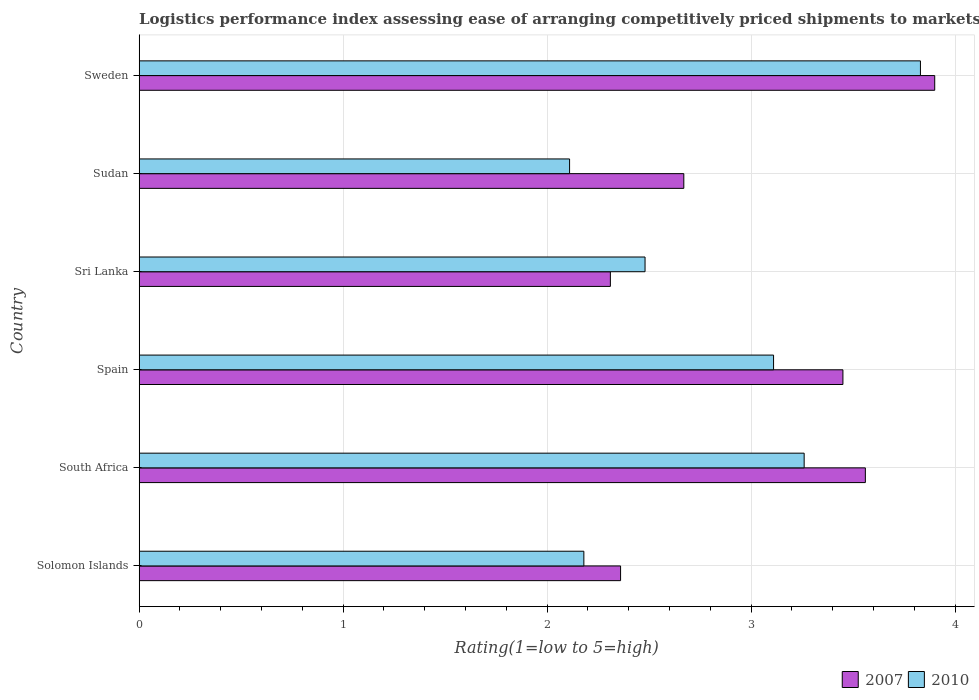Are the number of bars per tick equal to the number of legend labels?
Offer a terse response. Yes. Are the number of bars on each tick of the Y-axis equal?
Give a very brief answer. Yes. How many bars are there on the 5th tick from the top?
Give a very brief answer. 2. How many bars are there on the 2nd tick from the bottom?
Make the answer very short. 2. What is the label of the 5th group of bars from the top?
Ensure brevity in your answer.  South Africa. What is the Logistic performance index in 2007 in Sweden?
Your answer should be compact. 3.9. Across all countries, what is the minimum Logistic performance index in 2007?
Ensure brevity in your answer.  2.31. In which country was the Logistic performance index in 2007 maximum?
Your response must be concise. Sweden. In which country was the Logistic performance index in 2010 minimum?
Give a very brief answer. Sudan. What is the total Logistic performance index in 2007 in the graph?
Your response must be concise. 18.25. What is the difference between the Logistic performance index in 2010 in Solomon Islands and that in Spain?
Your answer should be compact. -0.93. What is the difference between the Logistic performance index in 2010 in Spain and the Logistic performance index in 2007 in Sudan?
Keep it short and to the point. 0.44. What is the average Logistic performance index in 2007 per country?
Offer a terse response. 3.04. What is the difference between the Logistic performance index in 2010 and Logistic performance index in 2007 in Solomon Islands?
Your answer should be very brief. -0.18. What is the ratio of the Logistic performance index in 2007 in Solomon Islands to that in Spain?
Your answer should be compact. 0.68. Is the Logistic performance index in 2007 in Solomon Islands less than that in Sudan?
Keep it short and to the point. Yes. Is the difference between the Logistic performance index in 2010 in South Africa and Sweden greater than the difference between the Logistic performance index in 2007 in South Africa and Sweden?
Your answer should be very brief. No. What is the difference between the highest and the second highest Logistic performance index in 2007?
Provide a succinct answer. 0.34. What is the difference between the highest and the lowest Logistic performance index in 2010?
Your answer should be very brief. 1.72. How many bars are there?
Your answer should be compact. 12. Are all the bars in the graph horizontal?
Give a very brief answer. Yes. How many countries are there in the graph?
Your answer should be compact. 6. Does the graph contain any zero values?
Ensure brevity in your answer.  No. How many legend labels are there?
Your answer should be compact. 2. What is the title of the graph?
Keep it short and to the point. Logistics performance index assessing ease of arranging competitively priced shipments to markets. What is the label or title of the X-axis?
Your response must be concise. Rating(1=low to 5=high). What is the Rating(1=low to 5=high) of 2007 in Solomon Islands?
Provide a short and direct response. 2.36. What is the Rating(1=low to 5=high) in 2010 in Solomon Islands?
Give a very brief answer. 2.18. What is the Rating(1=low to 5=high) of 2007 in South Africa?
Ensure brevity in your answer.  3.56. What is the Rating(1=low to 5=high) in 2010 in South Africa?
Your response must be concise. 3.26. What is the Rating(1=low to 5=high) in 2007 in Spain?
Ensure brevity in your answer.  3.45. What is the Rating(1=low to 5=high) in 2010 in Spain?
Make the answer very short. 3.11. What is the Rating(1=low to 5=high) in 2007 in Sri Lanka?
Offer a terse response. 2.31. What is the Rating(1=low to 5=high) of 2010 in Sri Lanka?
Offer a very short reply. 2.48. What is the Rating(1=low to 5=high) of 2007 in Sudan?
Your answer should be compact. 2.67. What is the Rating(1=low to 5=high) in 2010 in Sudan?
Make the answer very short. 2.11. What is the Rating(1=low to 5=high) in 2007 in Sweden?
Your response must be concise. 3.9. What is the Rating(1=low to 5=high) of 2010 in Sweden?
Make the answer very short. 3.83. Across all countries, what is the maximum Rating(1=low to 5=high) in 2010?
Provide a short and direct response. 3.83. Across all countries, what is the minimum Rating(1=low to 5=high) in 2007?
Provide a short and direct response. 2.31. Across all countries, what is the minimum Rating(1=low to 5=high) in 2010?
Ensure brevity in your answer.  2.11. What is the total Rating(1=low to 5=high) of 2007 in the graph?
Keep it short and to the point. 18.25. What is the total Rating(1=low to 5=high) in 2010 in the graph?
Provide a short and direct response. 16.97. What is the difference between the Rating(1=low to 5=high) of 2010 in Solomon Islands and that in South Africa?
Your answer should be very brief. -1.08. What is the difference between the Rating(1=low to 5=high) in 2007 in Solomon Islands and that in Spain?
Your answer should be very brief. -1.09. What is the difference between the Rating(1=low to 5=high) of 2010 in Solomon Islands and that in Spain?
Keep it short and to the point. -0.93. What is the difference between the Rating(1=low to 5=high) of 2007 in Solomon Islands and that in Sudan?
Provide a short and direct response. -0.31. What is the difference between the Rating(1=low to 5=high) in 2010 in Solomon Islands and that in Sudan?
Provide a succinct answer. 0.07. What is the difference between the Rating(1=low to 5=high) in 2007 in Solomon Islands and that in Sweden?
Offer a terse response. -1.54. What is the difference between the Rating(1=low to 5=high) in 2010 in Solomon Islands and that in Sweden?
Offer a terse response. -1.65. What is the difference between the Rating(1=low to 5=high) of 2007 in South Africa and that in Spain?
Your response must be concise. 0.11. What is the difference between the Rating(1=low to 5=high) in 2007 in South Africa and that in Sri Lanka?
Provide a short and direct response. 1.25. What is the difference between the Rating(1=low to 5=high) in 2010 in South Africa and that in Sri Lanka?
Provide a short and direct response. 0.78. What is the difference between the Rating(1=low to 5=high) of 2007 in South Africa and that in Sudan?
Give a very brief answer. 0.89. What is the difference between the Rating(1=low to 5=high) of 2010 in South Africa and that in Sudan?
Your response must be concise. 1.15. What is the difference between the Rating(1=low to 5=high) in 2007 in South Africa and that in Sweden?
Provide a short and direct response. -0.34. What is the difference between the Rating(1=low to 5=high) of 2010 in South Africa and that in Sweden?
Provide a short and direct response. -0.57. What is the difference between the Rating(1=low to 5=high) of 2007 in Spain and that in Sri Lanka?
Your response must be concise. 1.14. What is the difference between the Rating(1=low to 5=high) of 2010 in Spain and that in Sri Lanka?
Give a very brief answer. 0.63. What is the difference between the Rating(1=low to 5=high) of 2007 in Spain and that in Sudan?
Keep it short and to the point. 0.78. What is the difference between the Rating(1=low to 5=high) in 2007 in Spain and that in Sweden?
Your response must be concise. -0.45. What is the difference between the Rating(1=low to 5=high) of 2010 in Spain and that in Sweden?
Offer a terse response. -0.72. What is the difference between the Rating(1=low to 5=high) of 2007 in Sri Lanka and that in Sudan?
Provide a succinct answer. -0.36. What is the difference between the Rating(1=low to 5=high) of 2010 in Sri Lanka and that in Sudan?
Make the answer very short. 0.37. What is the difference between the Rating(1=low to 5=high) of 2007 in Sri Lanka and that in Sweden?
Offer a very short reply. -1.59. What is the difference between the Rating(1=low to 5=high) in 2010 in Sri Lanka and that in Sweden?
Give a very brief answer. -1.35. What is the difference between the Rating(1=low to 5=high) in 2007 in Sudan and that in Sweden?
Your answer should be compact. -1.23. What is the difference between the Rating(1=low to 5=high) of 2010 in Sudan and that in Sweden?
Offer a terse response. -1.72. What is the difference between the Rating(1=low to 5=high) in 2007 in Solomon Islands and the Rating(1=low to 5=high) in 2010 in South Africa?
Provide a succinct answer. -0.9. What is the difference between the Rating(1=low to 5=high) in 2007 in Solomon Islands and the Rating(1=low to 5=high) in 2010 in Spain?
Provide a succinct answer. -0.75. What is the difference between the Rating(1=low to 5=high) in 2007 in Solomon Islands and the Rating(1=low to 5=high) in 2010 in Sri Lanka?
Give a very brief answer. -0.12. What is the difference between the Rating(1=low to 5=high) of 2007 in Solomon Islands and the Rating(1=low to 5=high) of 2010 in Sweden?
Offer a terse response. -1.47. What is the difference between the Rating(1=low to 5=high) in 2007 in South Africa and the Rating(1=low to 5=high) in 2010 in Spain?
Offer a terse response. 0.45. What is the difference between the Rating(1=low to 5=high) of 2007 in South Africa and the Rating(1=low to 5=high) of 2010 in Sudan?
Make the answer very short. 1.45. What is the difference between the Rating(1=low to 5=high) in 2007 in South Africa and the Rating(1=low to 5=high) in 2010 in Sweden?
Offer a very short reply. -0.27. What is the difference between the Rating(1=low to 5=high) of 2007 in Spain and the Rating(1=low to 5=high) of 2010 in Sri Lanka?
Offer a terse response. 0.97. What is the difference between the Rating(1=low to 5=high) in 2007 in Spain and the Rating(1=low to 5=high) in 2010 in Sudan?
Your response must be concise. 1.34. What is the difference between the Rating(1=low to 5=high) in 2007 in Spain and the Rating(1=low to 5=high) in 2010 in Sweden?
Your answer should be compact. -0.38. What is the difference between the Rating(1=low to 5=high) in 2007 in Sri Lanka and the Rating(1=low to 5=high) in 2010 in Sweden?
Make the answer very short. -1.52. What is the difference between the Rating(1=low to 5=high) of 2007 in Sudan and the Rating(1=low to 5=high) of 2010 in Sweden?
Provide a short and direct response. -1.16. What is the average Rating(1=low to 5=high) of 2007 per country?
Offer a terse response. 3.04. What is the average Rating(1=low to 5=high) of 2010 per country?
Make the answer very short. 2.83. What is the difference between the Rating(1=low to 5=high) of 2007 and Rating(1=low to 5=high) of 2010 in Solomon Islands?
Ensure brevity in your answer.  0.18. What is the difference between the Rating(1=low to 5=high) of 2007 and Rating(1=low to 5=high) of 2010 in Spain?
Your answer should be very brief. 0.34. What is the difference between the Rating(1=low to 5=high) in 2007 and Rating(1=low to 5=high) in 2010 in Sri Lanka?
Your response must be concise. -0.17. What is the difference between the Rating(1=low to 5=high) of 2007 and Rating(1=low to 5=high) of 2010 in Sudan?
Your response must be concise. 0.56. What is the difference between the Rating(1=low to 5=high) in 2007 and Rating(1=low to 5=high) in 2010 in Sweden?
Provide a succinct answer. 0.07. What is the ratio of the Rating(1=low to 5=high) in 2007 in Solomon Islands to that in South Africa?
Make the answer very short. 0.66. What is the ratio of the Rating(1=low to 5=high) in 2010 in Solomon Islands to that in South Africa?
Your response must be concise. 0.67. What is the ratio of the Rating(1=low to 5=high) of 2007 in Solomon Islands to that in Spain?
Provide a short and direct response. 0.68. What is the ratio of the Rating(1=low to 5=high) of 2010 in Solomon Islands to that in Spain?
Your response must be concise. 0.7. What is the ratio of the Rating(1=low to 5=high) of 2007 in Solomon Islands to that in Sri Lanka?
Offer a terse response. 1.02. What is the ratio of the Rating(1=low to 5=high) in 2010 in Solomon Islands to that in Sri Lanka?
Offer a very short reply. 0.88. What is the ratio of the Rating(1=low to 5=high) of 2007 in Solomon Islands to that in Sudan?
Make the answer very short. 0.88. What is the ratio of the Rating(1=low to 5=high) in 2010 in Solomon Islands to that in Sudan?
Provide a short and direct response. 1.03. What is the ratio of the Rating(1=low to 5=high) in 2007 in Solomon Islands to that in Sweden?
Keep it short and to the point. 0.61. What is the ratio of the Rating(1=low to 5=high) in 2010 in Solomon Islands to that in Sweden?
Give a very brief answer. 0.57. What is the ratio of the Rating(1=low to 5=high) of 2007 in South Africa to that in Spain?
Give a very brief answer. 1.03. What is the ratio of the Rating(1=low to 5=high) of 2010 in South Africa to that in Spain?
Your answer should be very brief. 1.05. What is the ratio of the Rating(1=low to 5=high) of 2007 in South Africa to that in Sri Lanka?
Ensure brevity in your answer.  1.54. What is the ratio of the Rating(1=low to 5=high) in 2010 in South Africa to that in Sri Lanka?
Give a very brief answer. 1.31. What is the ratio of the Rating(1=low to 5=high) of 2007 in South Africa to that in Sudan?
Your response must be concise. 1.33. What is the ratio of the Rating(1=low to 5=high) in 2010 in South Africa to that in Sudan?
Give a very brief answer. 1.54. What is the ratio of the Rating(1=low to 5=high) in 2007 in South Africa to that in Sweden?
Provide a succinct answer. 0.91. What is the ratio of the Rating(1=low to 5=high) of 2010 in South Africa to that in Sweden?
Your answer should be compact. 0.85. What is the ratio of the Rating(1=low to 5=high) of 2007 in Spain to that in Sri Lanka?
Offer a terse response. 1.49. What is the ratio of the Rating(1=low to 5=high) in 2010 in Spain to that in Sri Lanka?
Give a very brief answer. 1.25. What is the ratio of the Rating(1=low to 5=high) in 2007 in Spain to that in Sudan?
Provide a short and direct response. 1.29. What is the ratio of the Rating(1=low to 5=high) in 2010 in Spain to that in Sudan?
Your answer should be very brief. 1.47. What is the ratio of the Rating(1=low to 5=high) of 2007 in Spain to that in Sweden?
Offer a terse response. 0.88. What is the ratio of the Rating(1=low to 5=high) of 2010 in Spain to that in Sweden?
Provide a succinct answer. 0.81. What is the ratio of the Rating(1=low to 5=high) of 2007 in Sri Lanka to that in Sudan?
Give a very brief answer. 0.87. What is the ratio of the Rating(1=low to 5=high) of 2010 in Sri Lanka to that in Sudan?
Your response must be concise. 1.18. What is the ratio of the Rating(1=low to 5=high) in 2007 in Sri Lanka to that in Sweden?
Provide a short and direct response. 0.59. What is the ratio of the Rating(1=low to 5=high) of 2010 in Sri Lanka to that in Sweden?
Make the answer very short. 0.65. What is the ratio of the Rating(1=low to 5=high) of 2007 in Sudan to that in Sweden?
Ensure brevity in your answer.  0.68. What is the ratio of the Rating(1=low to 5=high) of 2010 in Sudan to that in Sweden?
Offer a terse response. 0.55. What is the difference between the highest and the second highest Rating(1=low to 5=high) of 2007?
Provide a short and direct response. 0.34. What is the difference between the highest and the second highest Rating(1=low to 5=high) in 2010?
Provide a succinct answer. 0.57. What is the difference between the highest and the lowest Rating(1=low to 5=high) in 2007?
Give a very brief answer. 1.59. What is the difference between the highest and the lowest Rating(1=low to 5=high) of 2010?
Provide a short and direct response. 1.72. 